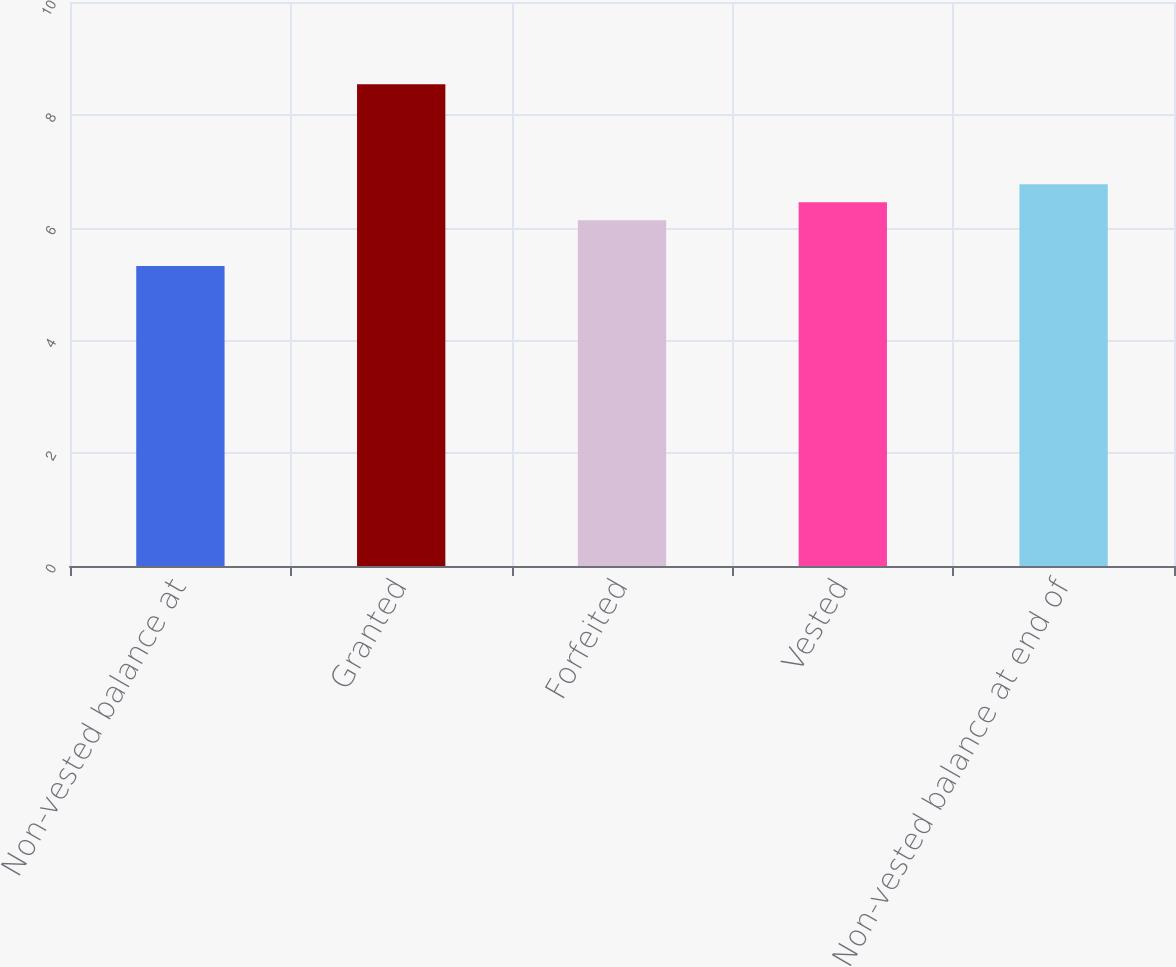Convert chart to OTSL. <chart><loc_0><loc_0><loc_500><loc_500><bar_chart><fcel>Non-vested balance at<fcel>Granted<fcel>Forfeited<fcel>Vested<fcel>Non-vested balance at end of<nl><fcel>5.32<fcel>8.54<fcel>6.13<fcel>6.45<fcel>6.77<nl></chart> 